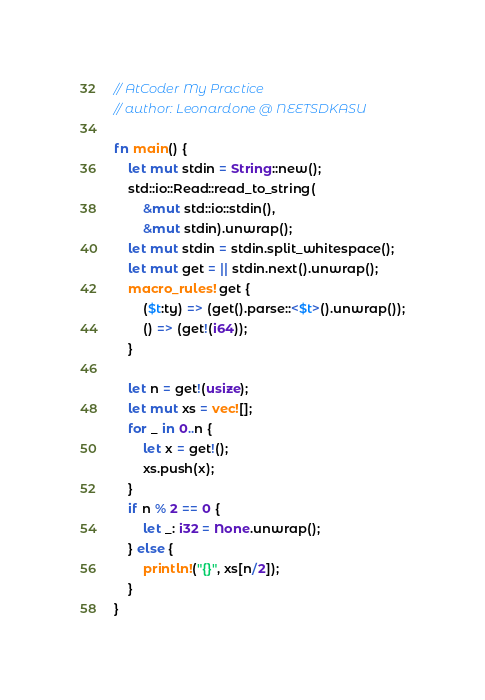<code> <loc_0><loc_0><loc_500><loc_500><_Rust_>// AtCoder My Practice
// author: Leonardone @ NEETSDKASU

fn main() {
	let mut stdin = String::new();
    std::io::Read::read_to_string(
    	&mut std::io::stdin(),
        &mut stdin).unwrap();
	let mut stdin = stdin.split_whitespace();
    let mut get = || stdin.next().unwrap();
    macro_rules! get {
    	($t:ty) => (get().parse::<$t>().unwrap());
        () => (get!(i64));
    }
    
    let n = get!(usize);
    let mut xs = vec![];
    for _ in 0..n {
    	let x = get!();
        xs.push(x);
    }
    if n % 2 == 0 {
    	let _: i32 = None.unwrap();
    } else {
    	println!("{}", xs[n/2]);
    }
}</code> 